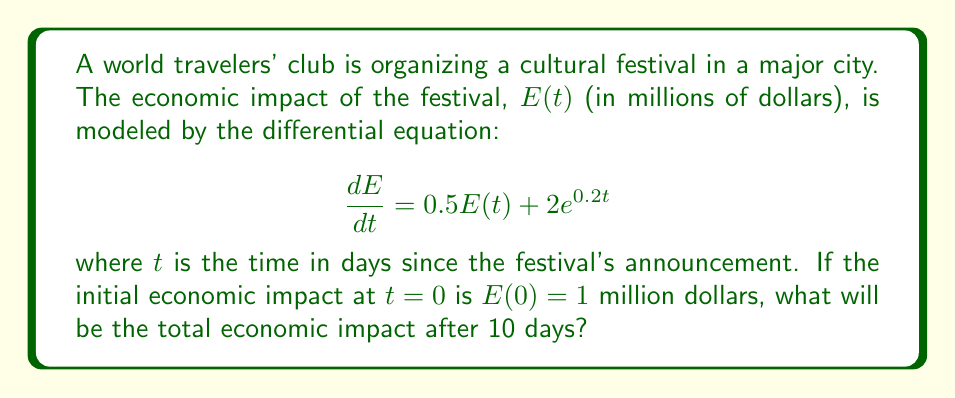Provide a solution to this math problem. To solve this problem, we need to follow these steps:

1) First, we recognize this as a first-order linear differential equation in the form:

   $$\frac{dE}{dt} + P(t)E = Q(t)$$

   where $P(t) = -0.5$ and $Q(t) = 2e^{0.2t}$

2) The general solution for this type of equation is:

   $$E(t) = e^{-\int P(t)dt} \left(\int Q(t)e^{\int P(t)dt}dt + C\right)$$

3) Let's solve each part:

   $\int P(t)dt = \int -0.5dt = -0.5t$

   $e^{\int P(t)dt} = e^{-0.5t}$

4) Now, we can set up the integral:

   $$E(t) = e^{0.5t} \left(\int 2e^{0.2t}e^{-0.5t}dt + C\right)$$

   $$= e^{0.5t} \left(\int 2e^{-0.3t}dt + C\right)$$

5) Solving the integral:

   $$= e^{0.5t} \left(-\frac{2}{0.3}e^{-0.3t} + C\right)$$

6) Simplifying:

   $$E(t) = -\frac{20}{3}e^{0.2t} + Ce^{0.5t}$$

7) Using the initial condition $E(0) = 1$:

   $$1 = -\frac{20}{3} + C$$

   $$C = 1 + \frac{20}{3} = \frac{23}{3}$$

8) Therefore, the particular solution is:

   $$E(t) = -\frac{20}{3}e^{0.2t} + \frac{23}{3}e^{0.5t}$$

9) To find the economic impact after 10 days, we substitute $t=10$:

   $$E(10) = -\frac{20}{3}e^{2} + \frac{23}{3}e^{5}$$

10) Calculating this value:

    $$E(10) \approx 125.51$$
Answer: The total economic impact after 10 days will be approximately $125.51 million. 